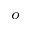<formula> <loc_0><loc_0><loc_500><loc_500>^ { o }</formula> 